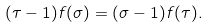Convert formula to latex. <formula><loc_0><loc_0><loc_500><loc_500>( \tau - 1 ) f ( \sigma ) = ( \sigma - 1 ) f ( \tau ) .</formula> 